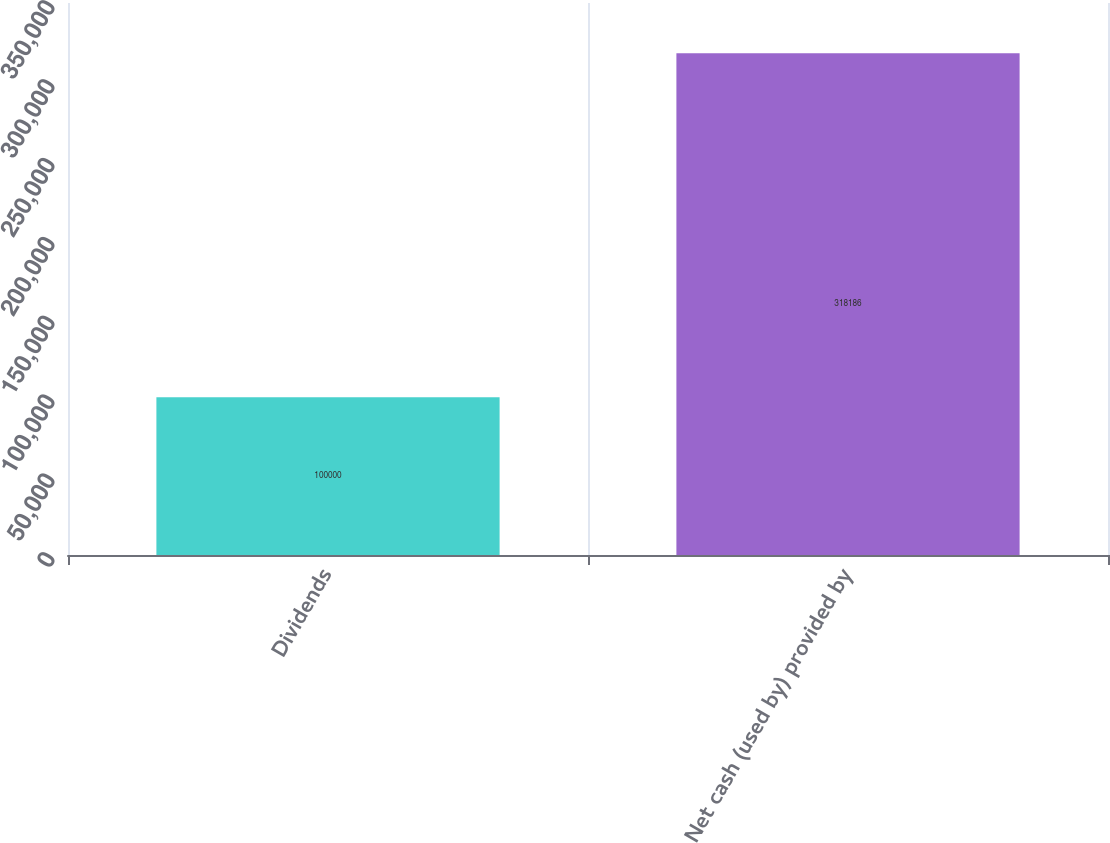Convert chart to OTSL. <chart><loc_0><loc_0><loc_500><loc_500><bar_chart><fcel>Dividends<fcel>Net cash (used by) provided by<nl><fcel>100000<fcel>318186<nl></chart> 